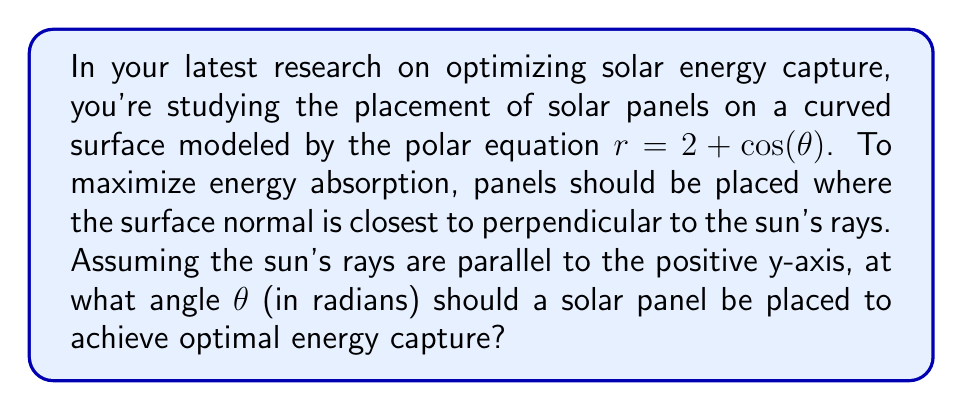Provide a solution to this math problem. To solve this problem, we need to follow these steps:

1) The normal to the surface at any point is perpendicular to the tangent line at that point. We need to find where this normal is parallel to the sun's rays (positive y-axis).

2) The general equation for the tangent line in polar coordinates is:

   $$\frac{dr}{d\theta} \sin\theta + r\cos\theta = \tan\phi(r\sin\theta - \frac{dr}{d\theta}\cos\theta)$$

   where $\phi$ is the angle between the tangent line and the positive x-axis.

3) We need to find $\frac{dr}{d\theta}$:
   
   $$\frac{dr}{d\theta} = -\sin(\theta)$$

4) Substituting into the tangent line equation:

   $$-\sin(\theta)\sin\theta + (2+\cos(\theta))\cos\theta = \tan\phi((2+\cos(\theta))\sin\theta + \sin(\theta)\cos\theta)$$

5) For the normal to be parallel to the y-axis, the tangent line must be perpendicular to the y-axis, meaning $\phi = 0$ or $\pi$. This makes $\tan\phi = 0$.

6) Our equation simplifies to:

   $$-\sin^2(\theta) + 2\cos(\theta) + \cos^2(\theta) = 0$$

7) Using the identity $\sin^2(\theta) + \cos^2(\theta) = 1$, we get:

   $$-1 + \cos^2(\theta) + 2\cos(\theta) + \cos^2(\theta) = 0$$
   $$2\cos^2(\theta) + 2\cos(\theta) - 1 = 0$$

8) This is a quadratic in $\cos(\theta)$. Solving it:

   $$\cos(\theta) = \frac{-2 \pm \sqrt{4 + 8}}{4} = \frac{-1 \pm \sqrt{3}}{2}$$

9) The positive solution gives us:

   $$\cos(\theta) = \frac{-1 + \sqrt{3}}{2}$$

10) Taking the inverse cosine of both sides:

    $$\theta = \arccos(\frac{-1 + \sqrt{3}}{2})$$

This is the angle at which the solar panel should be placed for optimal energy capture.
Answer: $\theta = \arccos(\frac{-1 + \sqrt{3}}{2}) \approx 0.5236$ radians 